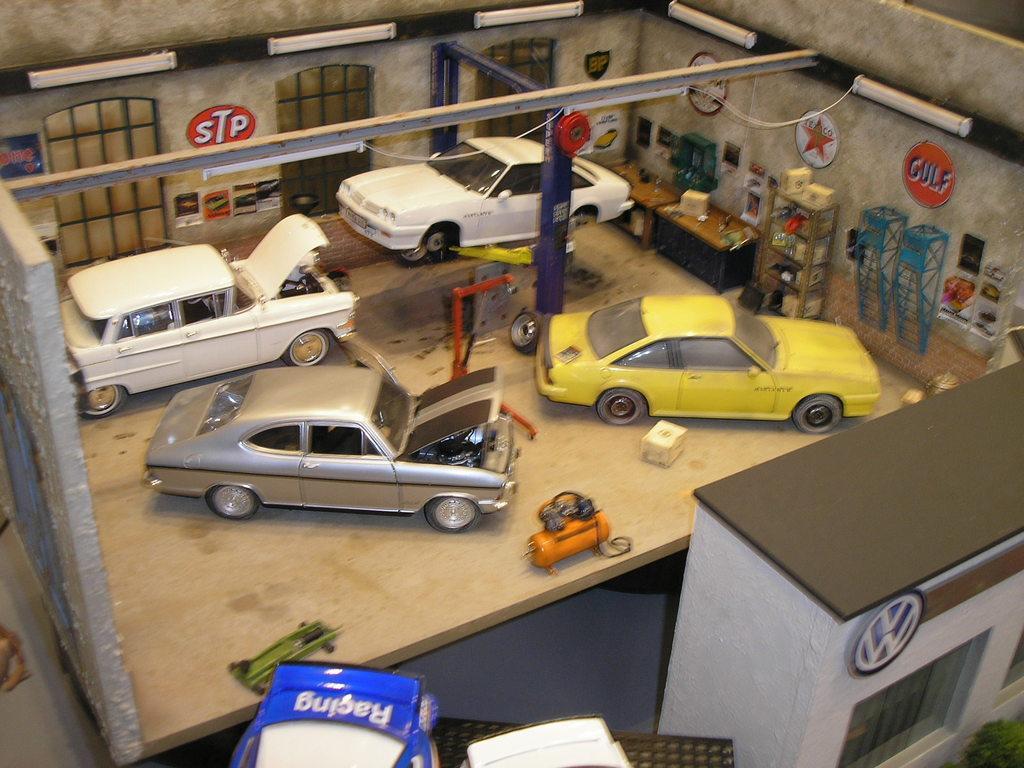How would you summarize this image in a sentence or two? This is looking like a shed. At the bottom there is a wall. In the middle of the image there are few cars on the ground and also two tables, a rack and some other objects are placed. In the background there are three windows a wall. On the right side there are few paintings on the wall. At the top there is a metal rod and on the left side there is a wall. 